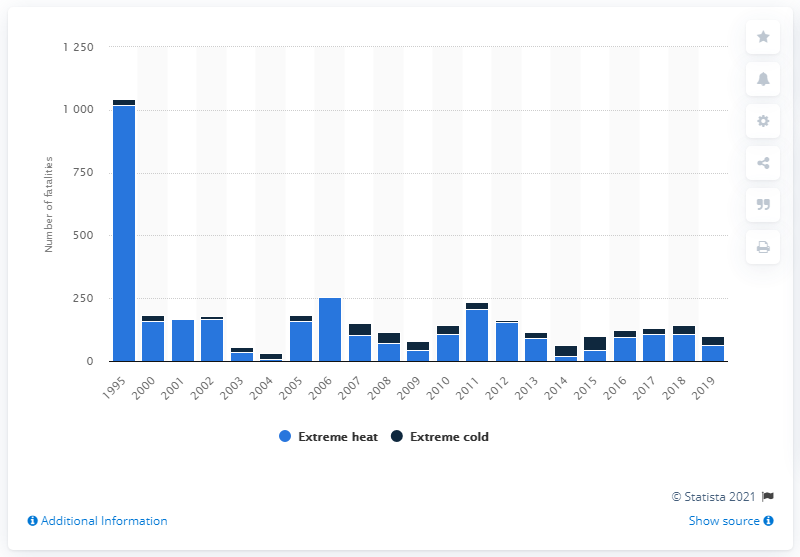Specify some key components in this picture. In 2019, 63 people in the United States died as a result of extreme weather events. 